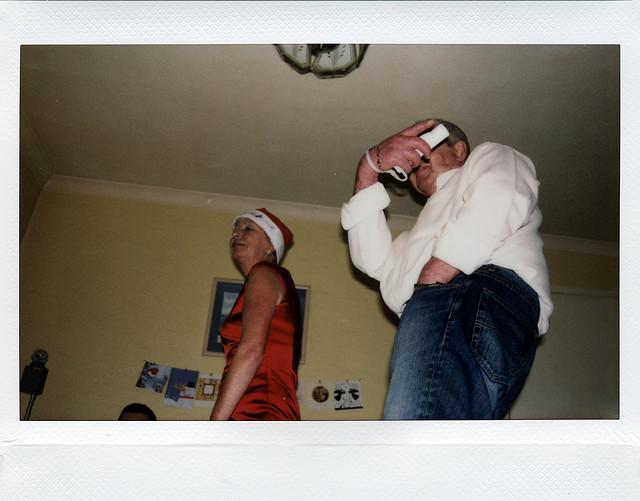Is the couple dancing?
Concise answer only. No. What kind of pants is the man wearing?
Answer briefly. Jeans. What is this person holding?
Write a very short answer. Wii remote. 